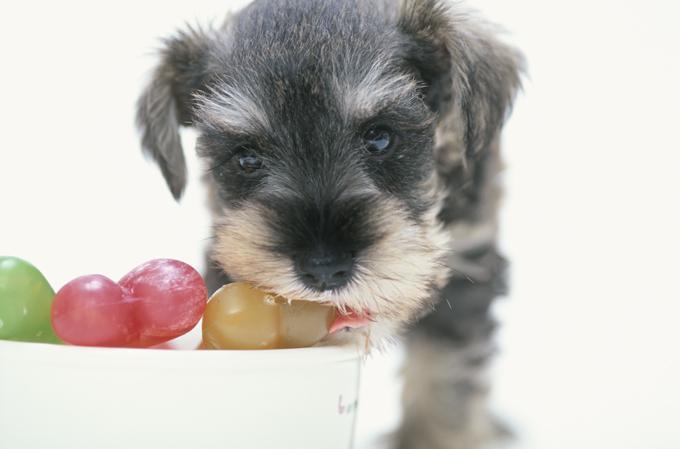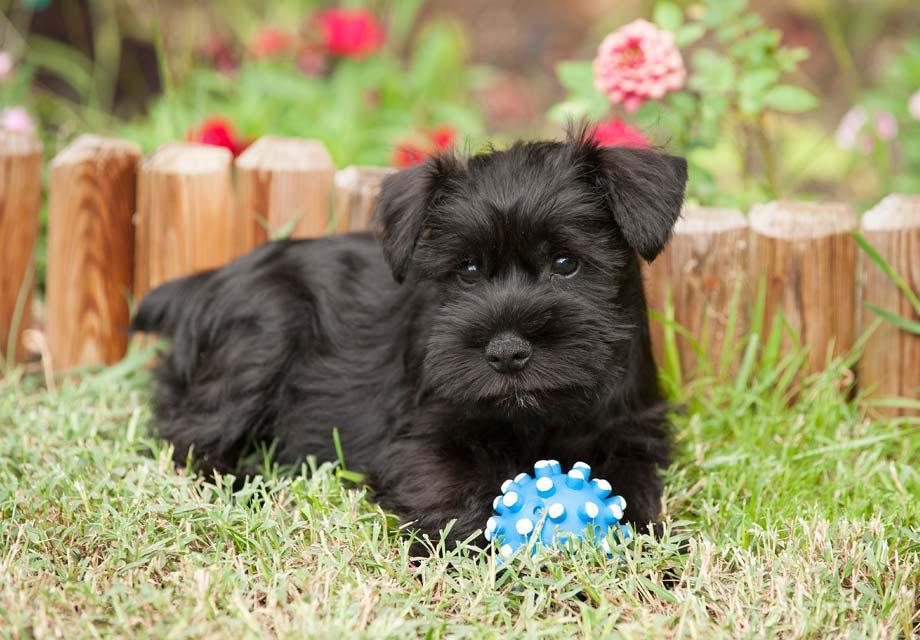The first image is the image on the left, the second image is the image on the right. Assess this claim about the two images: "The dog in the left photo is biting something.". Correct or not? Answer yes or no. Yes. The first image is the image on the left, the second image is the image on the right. Assess this claim about the two images: "In one image, a little dog with ears flopping forward has a blue toy at its front feet.". Correct or not? Answer yes or no. Yes. 